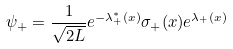<formula> <loc_0><loc_0><loc_500><loc_500>\psi _ { + } = \frac { 1 } { \sqrt { 2 L } } e ^ { - \lambda _ { + } ^ { * } ( x ) } \sigma _ { + } ( x ) e ^ { \lambda _ { + } ( x ) }</formula> 